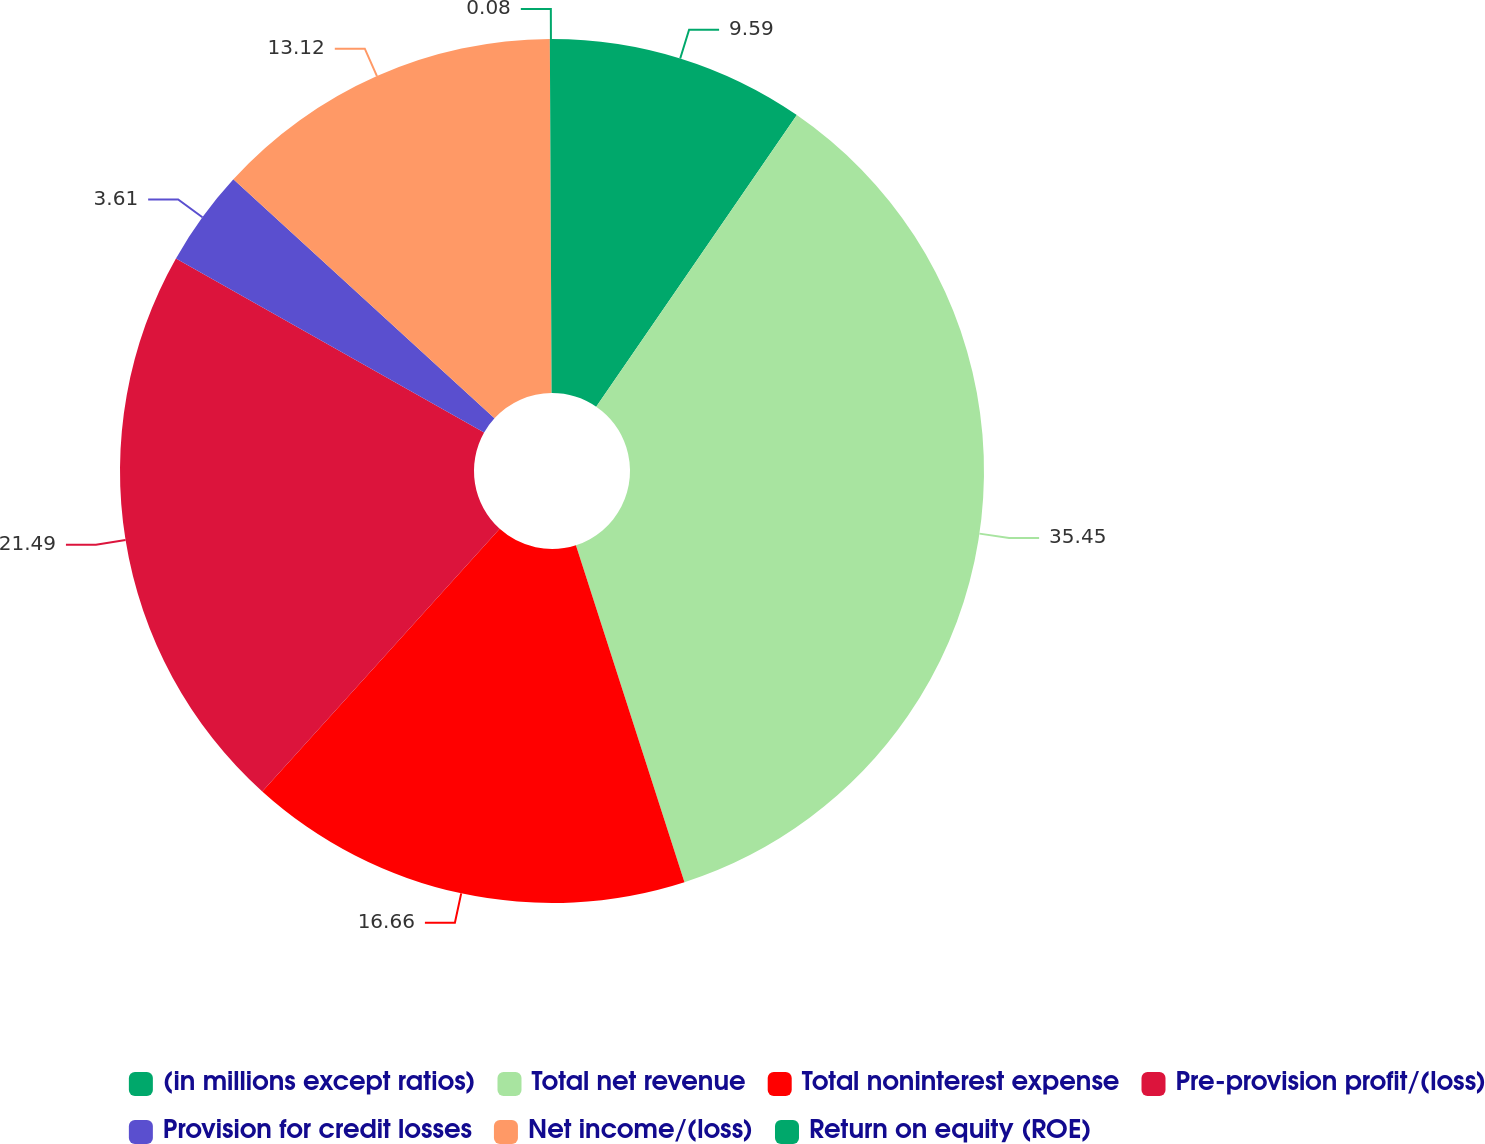Convert chart. <chart><loc_0><loc_0><loc_500><loc_500><pie_chart><fcel>(in millions except ratios)<fcel>Total net revenue<fcel>Total noninterest expense<fcel>Pre-provision profit/(loss)<fcel>Provision for credit losses<fcel>Net income/(loss)<fcel>Return on equity (ROE)<nl><fcel>9.59%<fcel>35.45%<fcel>16.66%<fcel>21.49%<fcel>3.61%<fcel>13.12%<fcel>0.08%<nl></chart> 